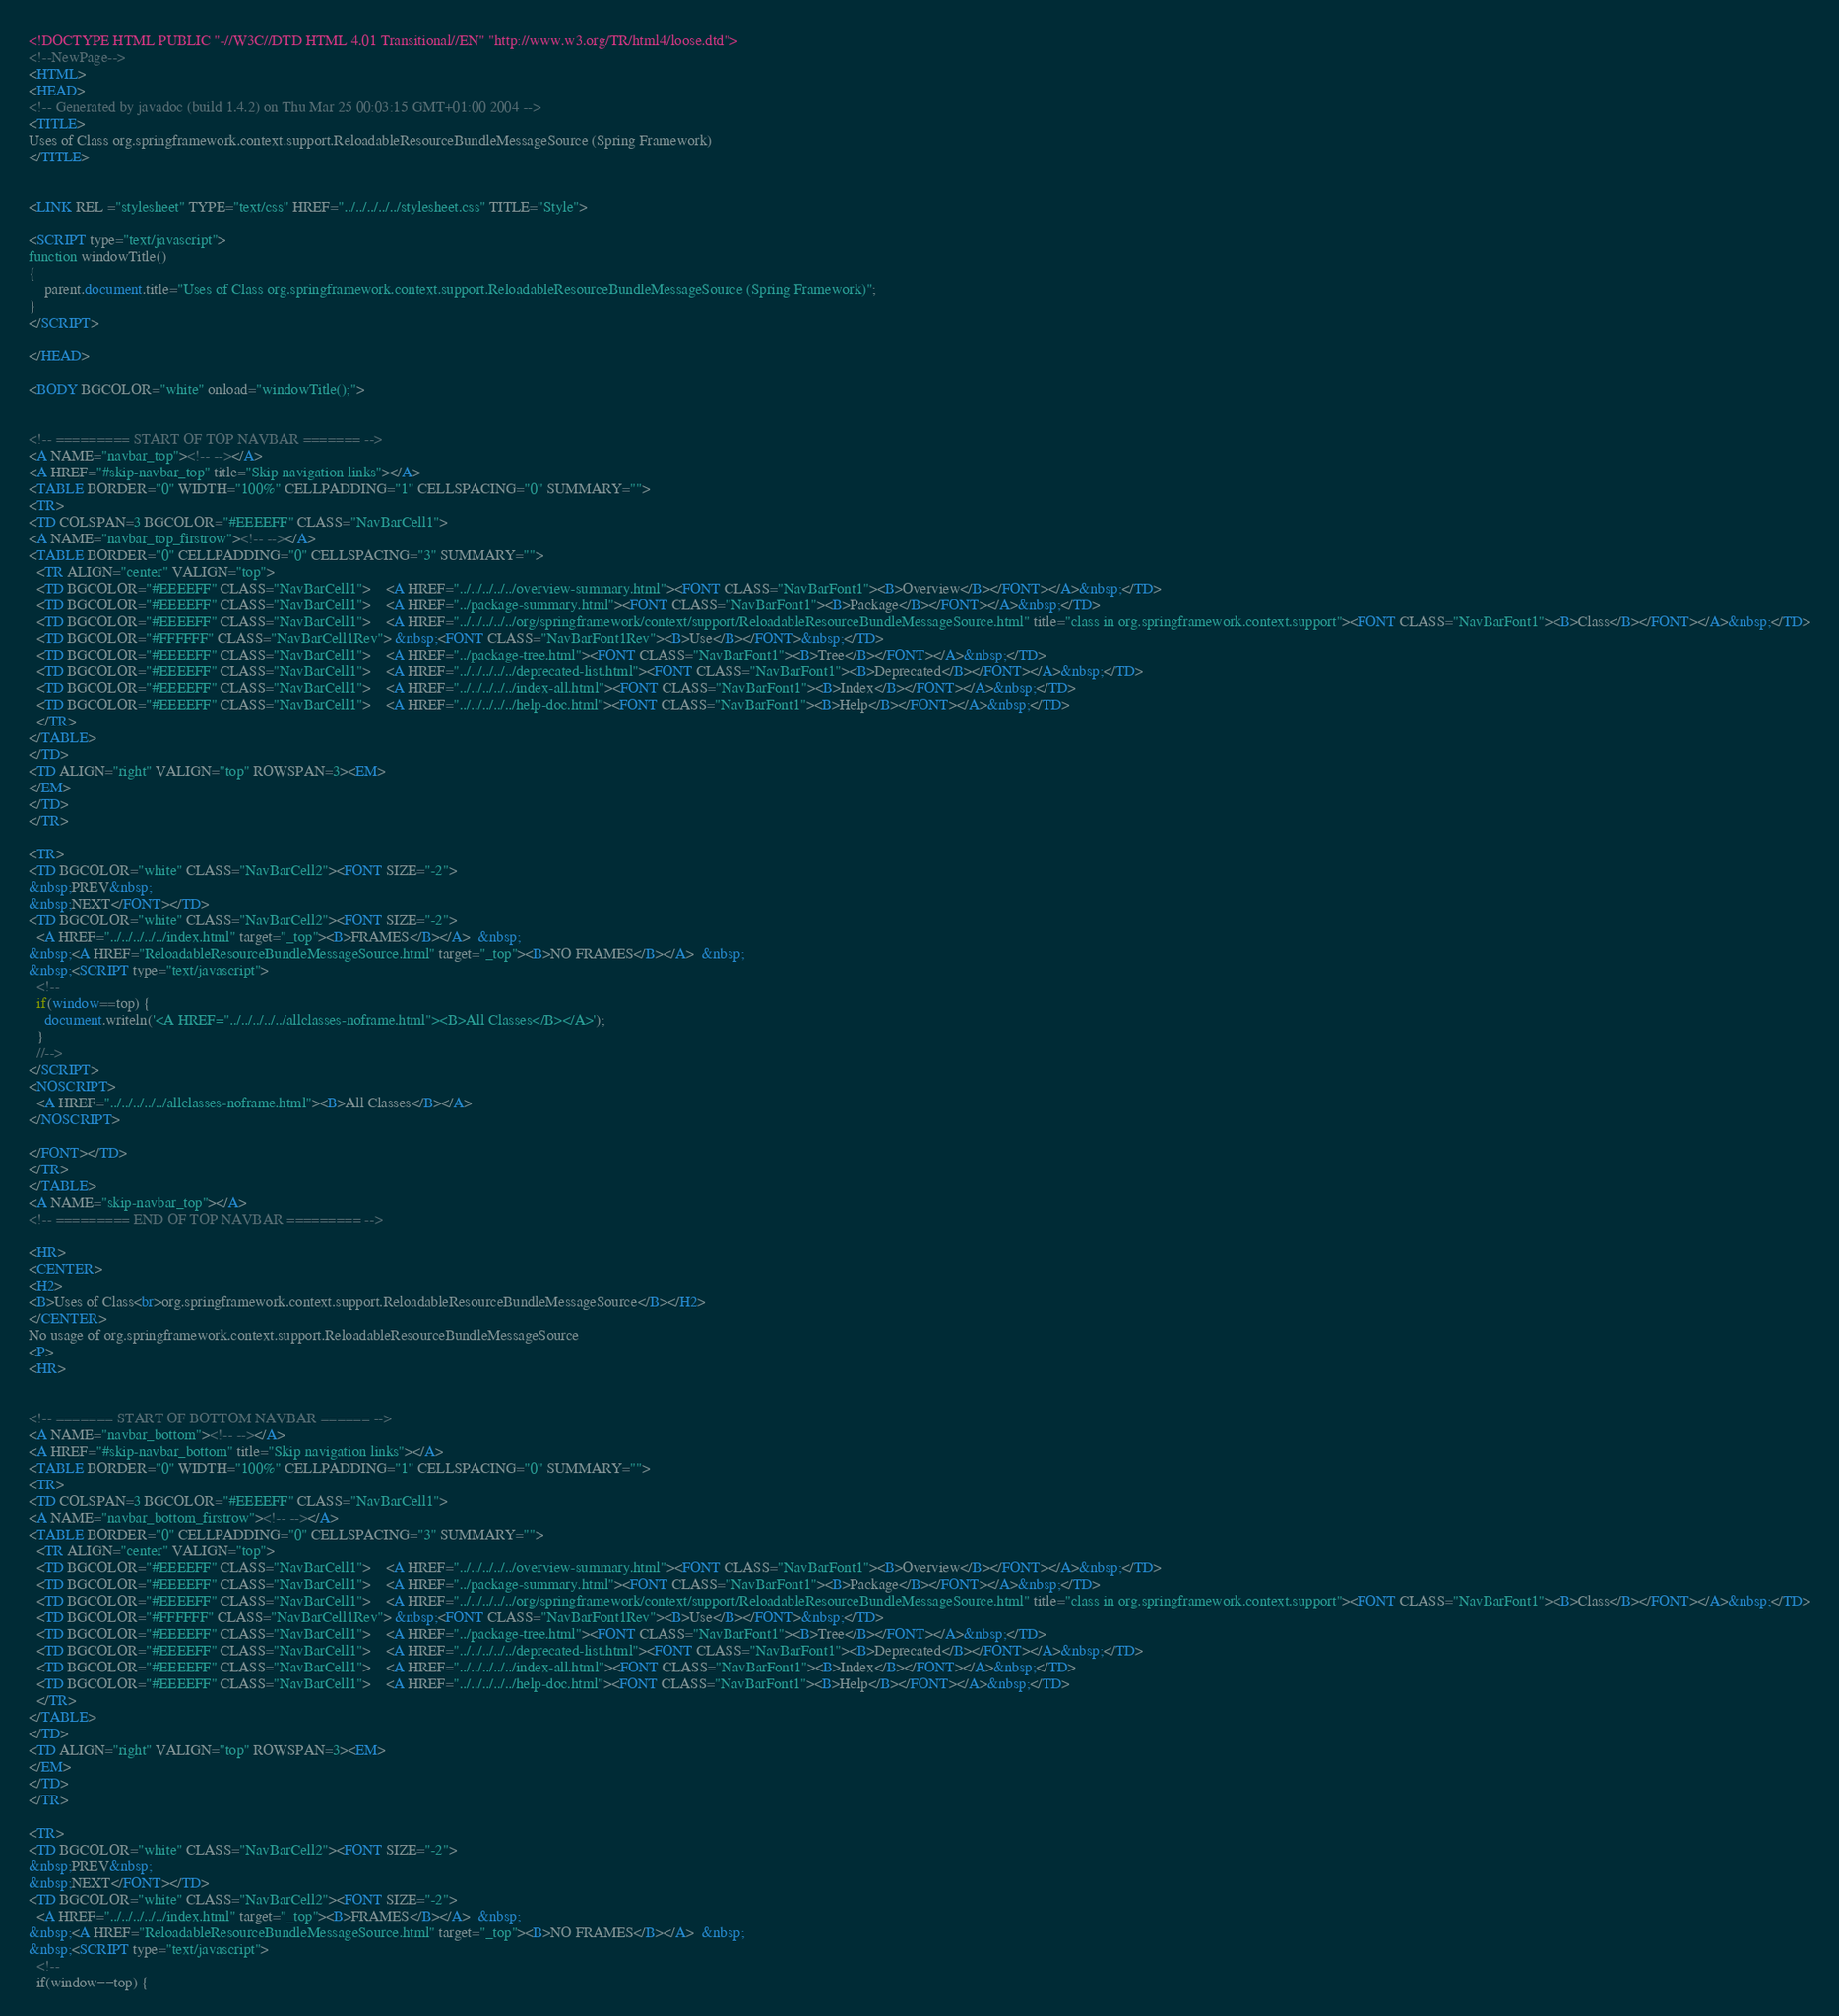<code> <loc_0><loc_0><loc_500><loc_500><_HTML_><!DOCTYPE HTML PUBLIC "-//W3C//DTD HTML 4.01 Transitional//EN" "http://www.w3.org/TR/html4/loose.dtd">
<!--NewPage-->
<HTML>
<HEAD>
<!-- Generated by javadoc (build 1.4.2) on Thu Mar 25 00:03:15 GMT+01:00 2004 -->
<TITLE>
Uses of Class org.springframework.context.support.ReloadableResourceBundleMessageSource (Spring Framework)
</TITLE>


<LINK REL ="stylesheet" TYPE="text/css" HREF="../../../../../stylesheet.css" TITLE="Style">

<SCRIPT type="text/javascript">
function windowTitle()
{
    parent.document.title="Uses of Class org.springframework.context.support.ReloadableResourceBundleMessageSource (Spring Framework)";
}
</SCRIPT>

</HEAD>

<BODY BGCOLOR="white" onload="windowTitle();">


<!-- ========= START OF TOP NAVBAR ======= -->
<A NAME="navbar_top"><!-- --></A>
<A HREF="#skip-navbar_top" title="Skip navigation links"></A>
<TABLE BORDER="0" WIDTH="100%" CELLPADDING="1" CELLSPACING="0" SUMMARY="">
<TR>
<TD COLSPAN=3 BGCOLOR="#EEEEFF" CLASS="NavBarCell1">
<A NAME="navbar_top_firstrow"><!-- --></A>
<TABLE BORDER="0" CELLPADDING="0" CELLSPACING="3" SUMMARY="">
  <TR ALIGN="center" VALIGN="top">
  <TD BGCOLOR="#EEEEFF" CLASS="NavBarCell1">    <A HREF="../../../../../overview-summary.html"><FONT CLASS="NavBarFont1"><B>Overview</B></FONT></A>&nbsp;</TD>
  <TD BGCOLOR="#EEEEFF" CLASS="NavBarCell1">    <A HREF="../package-summary.html"><FONT CLASS="NavBarFont1"><B>Package</B></FONT></A>&nbsp;</TD>
  <TD BGCOLOR="#EEEEFF" CLASS="NavBarCell1">    <A HREF="../../../../../org/springframework/context/support/ReloadableResourceBundleMessageSource.html" title="class in org.springframework.context.support"><FONT CLASS="NavBarFont1"><B>Class</B></FONT></A>&nbsp;</TD>
  <TD BGCOLOR="#FFFFFF" CLASS="NavBarCell1Rev"> &nbsp;<FONT CLASS="NavBarFont1Rev"><B>Use</B></FONT>&nbsp;</TD>
  <TD BGCOLOR="#EEEEFF" CLASS="NavBarCell1">    <A HREF="../package-tree.html"><FONT CLASS="NavBarFont1"><B>Tree</B></FONT></A>&nbsp;</TD>
  <TD BGCOLOR="#EEEEFF" CLASS="NavBarCell1">    <A HREF="../../../../../deprecated-list.html"><FONT CLASS="NavBarFont1"><B>Deprecated</B></FONT></A>&nbsp;</TD>
  <TD BGCOLOR="#EEEEFF" CLASS="NavBarCell1">    <A HREF="../../../../../index-all.html"><FONT CLASS="NavBarFont1"><B>Index</B></FONT></A>&nbsp;</TD>
  <TD BGCOLOR="#EEEEFF" CLASS="NavBarCell1">    <A HREF="../../../../../help-doc.html"><FONT CLASS="NavBarFont1"><B>Help</B></FONT></A>&nbsp;</TD>
  </TR>
</TABLE>
</TD>
<TD ALIGN="right" VALIGN="top" ROWSPAN=3><EM>
</EM>
</TD>
</TR>

<TR>
<TD BGCOLOR="white" CLASS="NavBarCell2"><FONT SIZE="-2">
&nbsp;PREV&nbsp;
&nbsp;NEXT</FONT></TD>
<TD BGCOLOR="white" CLASS="NavBarCell2"><FONT SIZE="-2">
  <A HREF="../../../../../index.html" target="_top"><B>FRAMES</B></A>  &nbsp;
&nbsp;<A HREF="ReloadableResourceBundleMessageSource.html" target="_top"><B>NO FRAMES</B></A>  &nbsp;
&nbsp;<SCRIPT type="text/javascript">
  <!--
  if(window==top) {
    document.writeln('<A HREF="../../../../../allclasses-noframe.html"><B>All Classes</B></A>');
  }
  //-->
</SCRIPT>
<NOSCRIPT>
  <A HREF="../../../../../allclasses-noframe.html"><B>All Classes</B></A>
</NOSCRIPT>

</FONT></TD>
</TR>
</TABLE>
<A NAME="skip-navbar_top"></A>
<!-- ========= END OF TOP NAVBAR ========= -->

<HR>
<CENTER>
<H2>
<B>Uses of Class<br>org.springframework.context.support.ReloadableResourceBundleMessageSource</B></H2>
</CENTER>
No usage of org.springframework.context.support.ReloadableResourceBundleMessageSource
<P>
<HR>


<!-- ======= START OF BOTTOM NAVBAR ====== -->
<A NAME="navbar_bottom"><!-- --></A>
<A HREF="#skip-navbar_bottom" title="Skip navigation links"></A>
<TABLE BORDER="0" WIDTH="100%" CELLPADDING="1" CELLSPACING="0" SUMMARY="">
<TR>
<TD COLSPAN=3 BGCOLOR="#EEEEFF" CLASS="NavBarCell1">
<A NAME="navbar_bottom_firstrow"><!-- --></A>
<TABLE BORDER="0" CELLPADDING="0" CELLSPACING="3" SUMMARY="">
  <TR ALIGN="center" VALIGN="top">
  <TD BGCOLOR="#EEEEFF" CLASS="NavBarCell1">    <A HREF="../../../../../overview-summary.html"><FONT CLASS="NavBarFont1"><B>Overview</B></FONT></A>&nbsp;</TD>
  <TD BGCOLOR="#EEEEFF" CLASS="NavBarCell1">    <A HREF="../package-summary.html"><FONT CLASS="NavBarFont1"><B>Package</B></FONT></A>&nbsp;</TD>
  <TD BGCOLOR="#EEEEFF" CLASS="NavBarCell1">    <A HREF="../../../../../org/springframework/context/support/ReloadableResourceBundleMessageSource.html" title="class in org.springframework.context.support"><FONT CLASS="NavBarFont1"><B>Class</B></FONT></A>&nbsp;</TD>
  <TD BGCOLOR="#FFFFFF" CLASS="NavBarCell1Rev"> &nbsp;<FONT CLASS="NavBarFont1Rev"><B>Use</B></FONT>&nbsp;</TD>
  <TD BGCOLOR="#EEEEFF" CLASS="NavBarCell1">    <A HREF="../package-tree.html"><FONT CLASS="NavBarFont1"><B>Tree</B></FONT></A>&nbsp;</TD>
  <TD BGCOLOR="#EEEEFF" CLASS="NavBarCell1">    <A HREF="../../../../../deprecated-list.html"><FONT CLASS="NavBarFont1"><B>Deprecated</B></FONT></A>&nbsp;</TD>
  <TD BGCOLOR="#EEEEFF" CLASS="NavBarCell1">    <A HREF="../../../../../index-all.html"><FONT CLASS="NavBarFont1"><B>Index</B></FONT></A>&nbsp;</TD>
  <TD BGCOLOR="#EEEEFF" CLASS="NavBarCell1">    <A HREF="../../../../../help-doc.html"><FONT CLASS="NavBarFont1"><B>Help</B></FONT></A>&nbsp;</TD>
  </TR>
</TABLE>
</TD>
<TD ALIGN="right" VALIGN="top" ROWSPAN=3><EM>
</EM>
</TD>
</TR>

<TR>
<TD BGCOLOR="white" CLASS="NavBarCell2"><FONT SIZE="-2">
&nbsp;PREV&nbsp;
&nbsp;NEXT</FONT></TD>
<TD BGCOLOR="white" CLASS="NavBarCell2"><FONT SIZE="-2">
  <A HREF="../../../../../index.html" target="_top"><B>FRAMES</B></A>  &nbsp;
&nbsp;<A HREF="ReloadableResourceBundleMessageSource.html" target="_top"><B>NO FRAMES</B></A>  &nbsp;
&nbsp;<SCRIPT type="text/javascript">
  <!--
  if(window==top) {</code> 